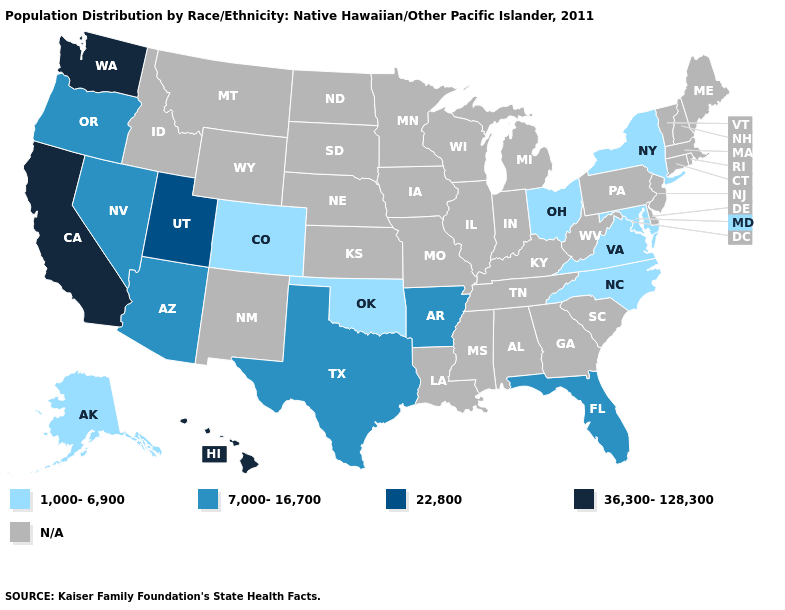What is the highest value in the USA?
Concise answer only. 36,300-128,300. Among the states that border Utah , which have the lowest value?
Concise answer only. Colorado. Which states hav the highest value in the West?
Give a very brief answer. California, Hawaii, Washington. Does the map have missing data?
Be succinct. Yes. What is the value of North Carolina?
Concise answer only. 1,000-6,900. What is the highest value in the South ?
Quick response, please. 7,000-16,700. What is the value of Pennsylvania?
Be succinct. N/A. Name the states that have a value in the range 1,000-6,900?
Keep it brief. Alaska, Colorado, Maryland, New York, North Carolina, Ohio, Oklahoma, Virginia. What is the value of Alaska?
Answer briefly. 1,000-6,900. Which states hav the highest value in the Northeast?
Concise answer only. New York. Name the states that have a value in the range N/A?
Quick response, please. Alabama, Connecticut, Delaware, Georgia, Idaho, Illinois, Indiana, Iowa, Kansas, Kentucky, Louisiana, Maine, Massachusetts, Michigan, Minnesota, Mississippi, Missouri, Montana, Nebraska, New Hampshire, New Jersey, New Mexico, North Dakota, Pennsylvania, Rhode Island, South Carolina, South Dakota, Tennessee, Vermont, West Virginia, Wisconsin, Wyoming. What is the highest value in the West ?
Concise answer only. 36,300-128,300. Name the states that have a value in the range 22,800?
Quick response, please. Utah. Name the states that have a value in the range 22,800?
Concise answer only. Utah. 